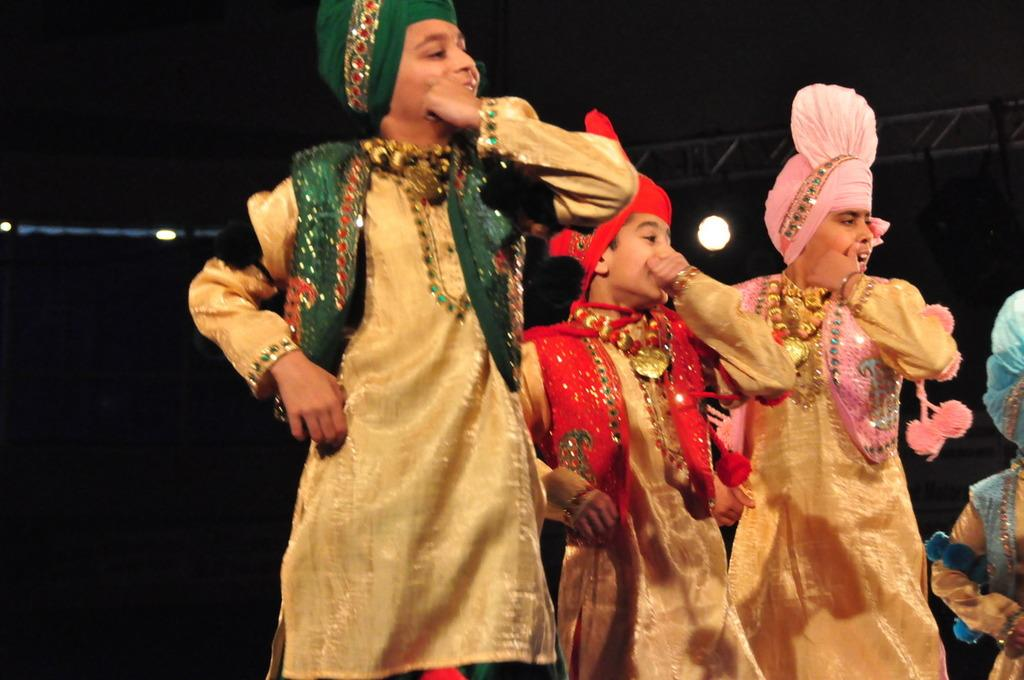How many children are in the image? There are children in the image, but the exact number is not specified. What are the children wearing? The children are wearing the same costume. What are the children doing in the image? The children are dancing. What can be seen in the background of the image? There are lights and a metal frame in the background of the image. How would you describe the lighting in the image? The background is dark, which suggests that the lighting is dim or low. Can you hear the children laughing in the image? There is no sound in the image, so it is not possible to hear the children laughing. 